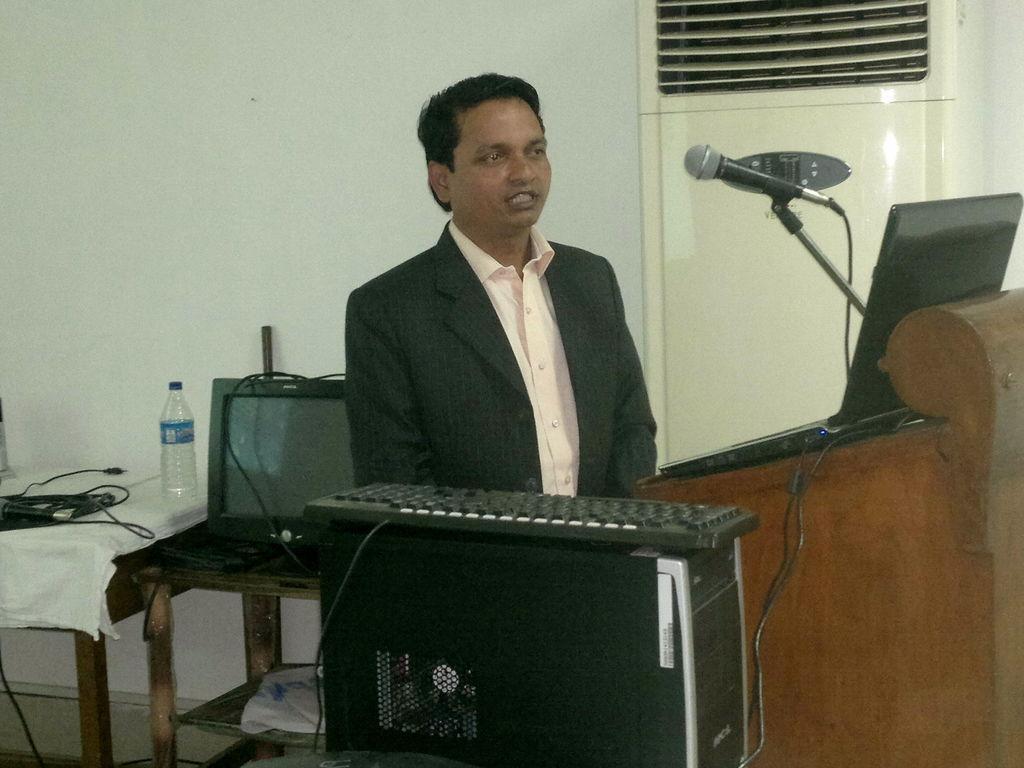How would you summarize this image in a sentence or two? There is a room. He is standing. He is wearing a black coat. On the right side we have a podium. There is a microphone,laptop on a podium. On the left side we have a table. There is a bottle,battery,TV on a table. We can see in background white color wall and window. 